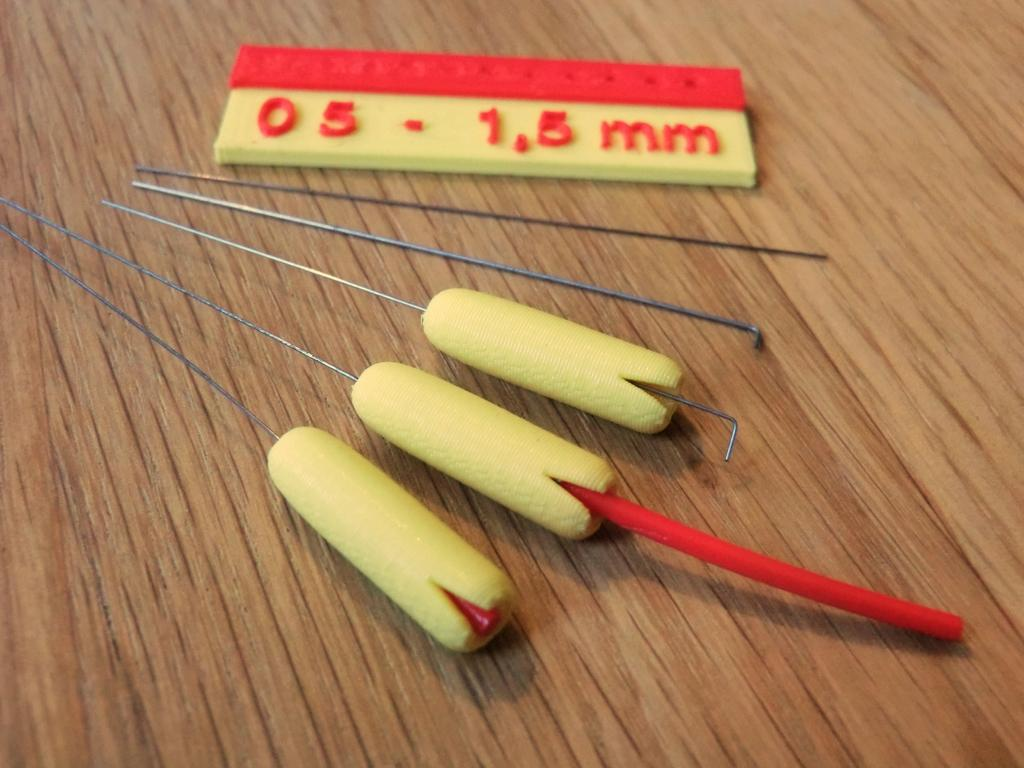What is present on the table in the image? There are objects on the table in the image. Can you identify any specific object on the table? Yes, there is a scale on the table in the image. What type of table is visible in the image? There is a wooden table in the image. What type of bushes can be seen growing around the table in the image? There are no bushes present in the image; it only features a table with objects on it. What idea is being discussed at the table in the image? The image does not provide any information about a discussion or idea being shared at the table. 